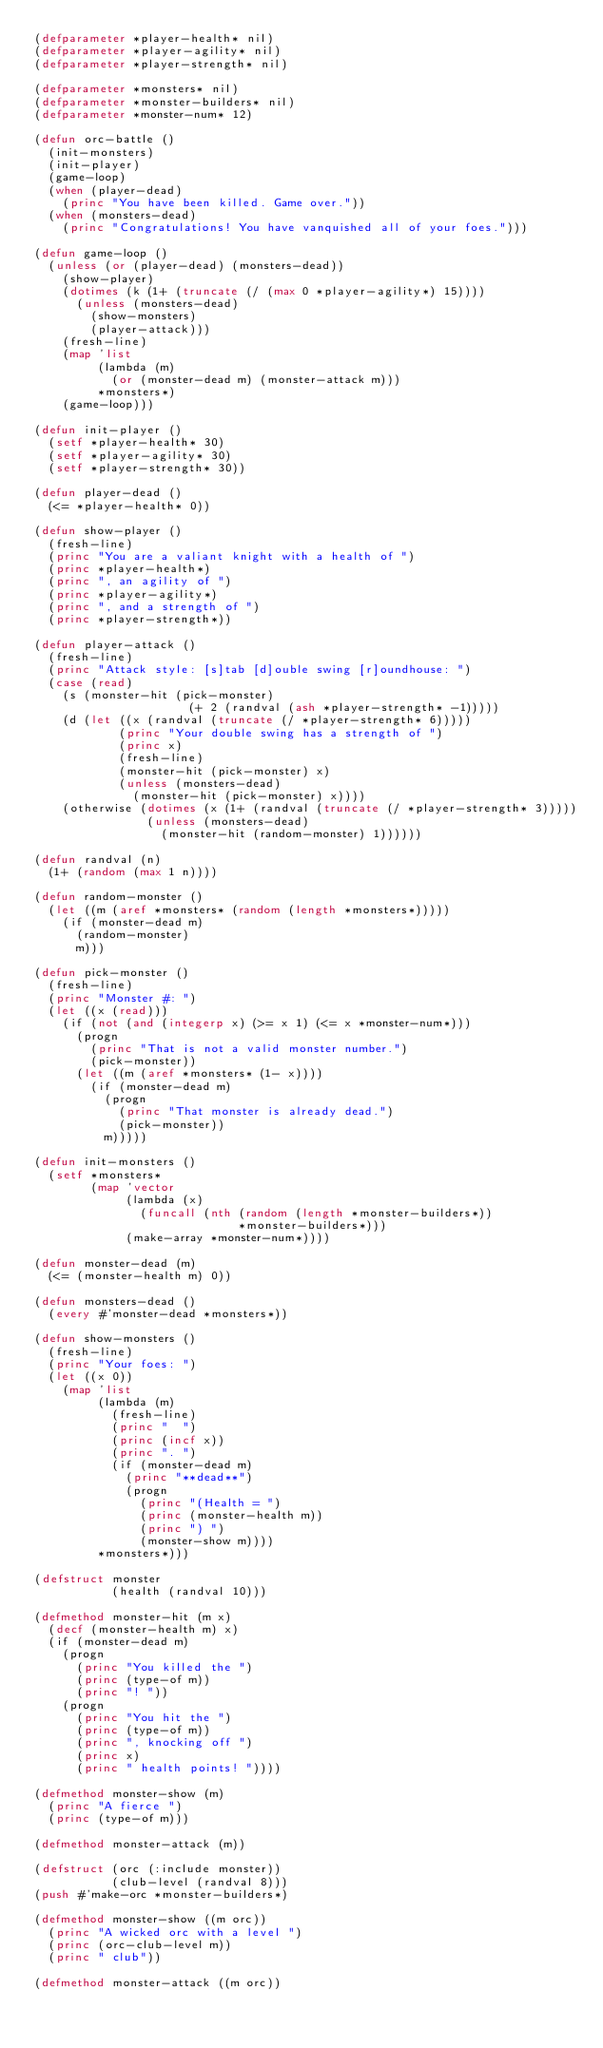<code> <loc_0><loc_0><loc_500><loc_500><_Lisp_>(defparameter *player-health* nil)
(defparameter *player-agility* nil)
(defparameter *player-strength* nil)

(defparameter *monsters* nil)
(defparameter *monster-builders* nil)
(defparameter *monster-num* 12)

(defun orc-battle ()
  (init-monsters)
  (init-player)
  (game-loop)
  (when (player-dead)
    (princ "You have been killed. Game over."))
  (when (monsters-dead)
    (princ "Congratulations! You have vanquished all of your foes.")))

(defun game-loop ()
  (unless (or (player-dead) (monsters-dead))
    (show-player)
    (dotimes (k (1+ (truncate (/ (max 0 *player-agility*) 15))))
      (unless (monsters-dead)
        (show-monsters)
        (player-attack)))
    (fresh-line)
    (map 'list
         (lambda (m)
           (or (monster-dead m) (monster-attack m)))
         *monsters*)
    (game-loop)))

(defun init-player ()
  (setf *player-health* 30)
  (setf *player-agility* 30)
  (setf *player-strength* 30))

(defun player-dead ()
  (<= *player-health* 0))

(defun show-player ()
  (fresh-line)
  (princ "You are a valiant knight with a health of ")
  (princ *player-health*)
  (princ ", an agility of ")
  (princ *player-agility*)
  (princ ", and a strength of ")
  (princ *player-strength*))

(defun player-attack ()
  (fresh-line)
  (princ "Attack style: [s]tab [d]ouble swing [r]oundhouse: ")
  (case (read)
    (s (monster-hit (pick-monster)
                      (+ 2 (randval (ash *player-strength* -1)))))
    (d (let ((x (randval (truncate (/ *player-strength* 6)))))
            (princ "Your double swing has a strength of ")
            (princ x)
            (fresh-line)
            (monster-hit (pick-monster) x)
            (unless (monsters-dead)
              (monster-hit (pick-monster) x))))
    (otherwise (dotimes (x (1+ (randval (truncate (/ *player-strength* 3)))))
                (unless (monsters-dead)
                  (monster-hit (random-monster) 1))))))

(defun randval (n)
  (1+ (random (max 1 n))))

(defun random-monster ()
  (let ((m (aref *monsters* (random (length *monsters*)))))
    (if (monster-dead m)
      (random-monster)
      m)))

(defun pick-monster ()
  (fresh-line)
  (princ "Monster #: ")
  (let ((x (read)))
    (if (not (and (integerp x) (>= x 1) (<= x *monster-num*)))
      (progn
        (princ "That is not a valid monster number.")
        (pick-monster))
      (let ((m (aref *monsters* (1- x))))
        (if (monster-dead m)
          (progn
            (princ "That monster is already dead.")
            (pick-monster))
          m)))))

(defun init-monsters ()
  (setf *monsters*
        (map 'vector 
             (lambda (x)
               (funcall (nth (random (length *monster-builders*))
                             *monster-builders*)))
             (make-array *monster-num*))))

(defun monster-dead (m)
  (<= (monster-health m) 0))

(defun monsters-dead ()
  (every #'monster-dead *monsters*))

(defun show-monsters ()
  (fresh-line)
  (princ "Your foes: ")
  (let ((x 0))
    (map 'list
         (lambda (m)
           (fresh-line)
           (princ "  ")
           (princ (incf x))
           (princ ". ")
           (if (monster-dead m)
             (princ "**dead**")
             (progn
               (princ "(Health = ")
               (princ (monster-health m))
               (princ ") ")
               (monster-show m))))
         *monsters*)))

(defstruct monster
           (health (randval 10)))

(defmethod monster-hit (m x)
  (decf (monster-health m) x)
  (if (monster-dead m)
    (progn
      (princ "You killed the ")
      (princ (type-of m))
      (princ "! "))
    (progn
      (princ "You hit the ")
      (princ (type-of m))
      (princ ", knocking off ")
      (princ x)
      (princ " health points! "))))

(defmethod monster-show (m)
  (princ "A fierce ")
  (princ (type-of m)))

(defmethod monster-attack (m))

(defstruct (orc (:include monster))
           (club-level (randval 8)))
(push #'make-orc *monster-builders*)

(defmethod monster-show ((m orc))
  (princ "A wicked orc with a level ")
  (princ (orc-club-level m))
  (princ " club"))

(defmethod monster-attack ((m orc))</code> 